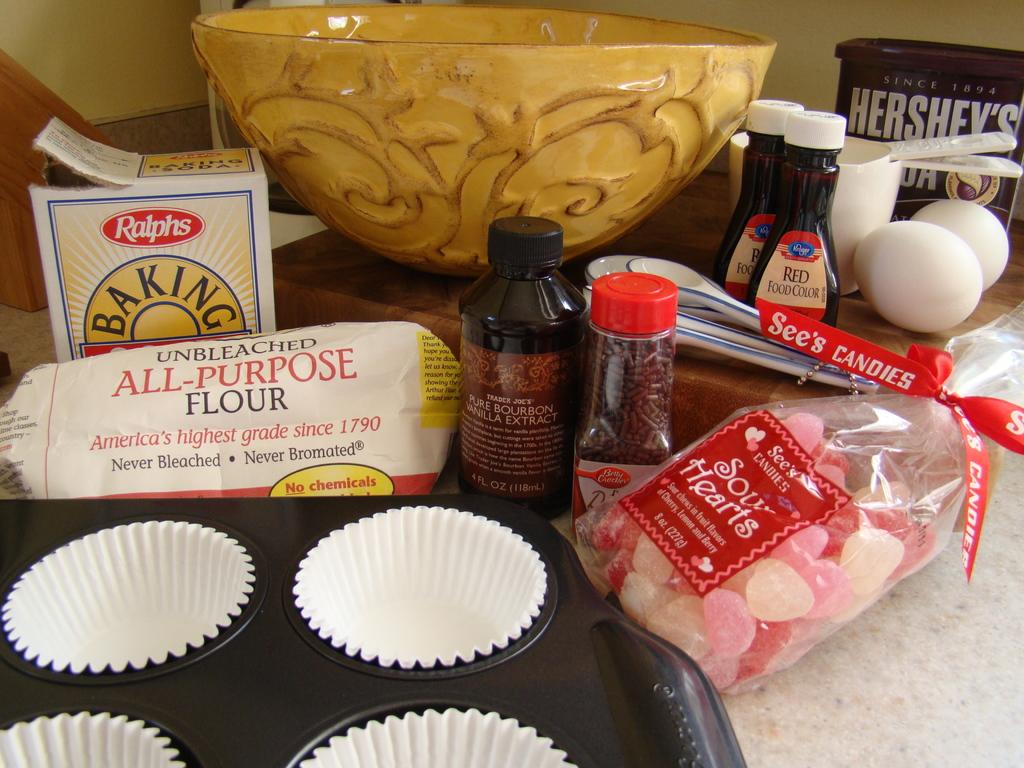What is the main subject of the image? The main subject of the image is a mold of muffins. What other baking-related items can be seen in the image? Baking groceries, eggs, food color, and Hershey's syrup are visible in the image. What type of container is present in the image? There is a bowl in the image. Where are all these items located? All these items are on a table. How many teeth can be seen in the image? There are no teeth visible in the image; it features baking groceries and related items. Is there an ant crawling on the table in the image? There is no ant present in the image; it only shows baking-related items on a table. 